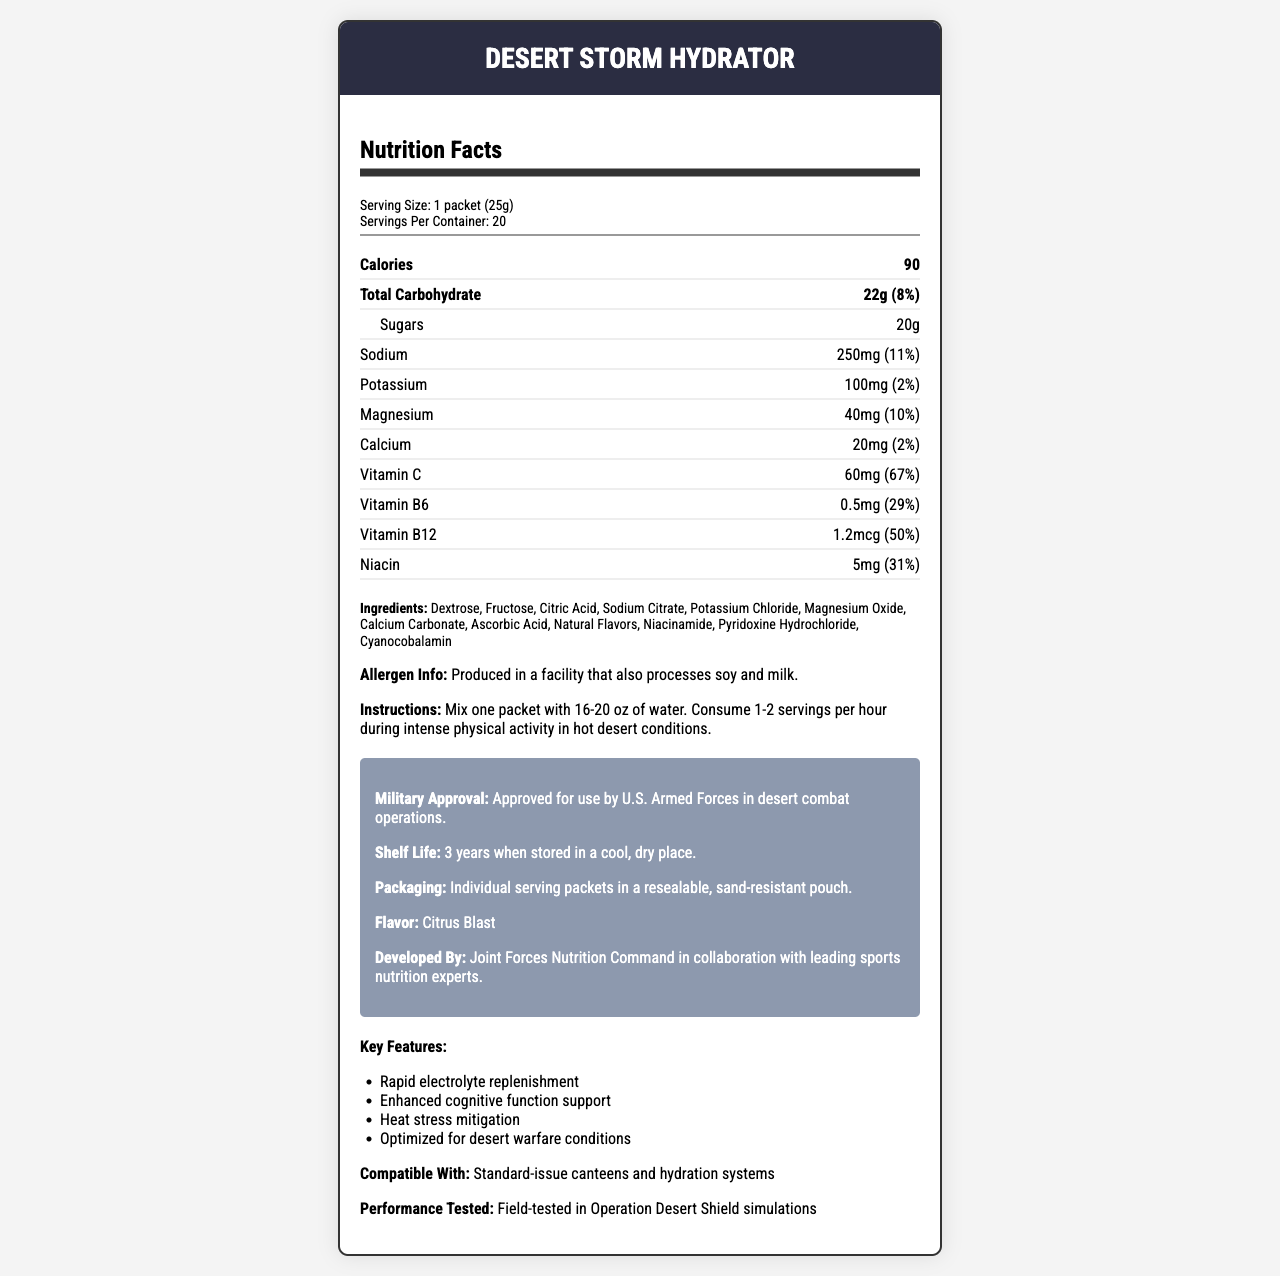what is the serving size for Desert Storm Hydrator? The document lists the serving size as 1 packet (25g).
Answer: 1 packet (25g) how many packets are there in each container? The servings per container are 20, which implies there are 20 packets.
Answer: 20 how many calories are in one serving? The document specifies that there are 90 calories per serving.
Answer: 90 how much sugar is in one serving? The sugar content per serving is listed as 20g.
Answer: 20g what are the ingredients listed for Desert Storm Hydrator? The ingredients are clearly listed in the document.
Answer: Dextrose, Fructose, Citric Acid, Sodium Citrate, Potassium Chloride, Magnesium Oxide, Calcium Carbonate, Ascorbic Acid, Natural Flavors, Niacinamide, Pyridoxine Hydrochloride, Cyanocobalamin how much sodium is in one serving of Desert Storm Hydrator? The document specifies that one serving contains 250mg of sodium.
Answer: 250mg which vitamin has the highest percentage of the daily value per serving? A. Vitamin C B. Vitamin B6 C. Vitamin B12 D. Niacin The document indicates Vitamin C at 67%, while Vitamin B6 is 29%, Vitamin B12 is 50%, and Niacin is 31%.
Answer: A. Vitamin C what flavor is Desert Storm Hydrator? A. Berry Burst B. Tropical Punch C. Citrus Blast D. Lemon Lime The document specifies the flavor as Citrus Blast.
Answer: C. Citrus Blast can Desert Storm Hydrator be used with standard-issue canteens and hydration systems? The document states that the product is compatible with standard-issue canteens and hydration systems.
Answer: Yes what is the shelf life of Desert Storm Hydrator? The document specifies a shelf life of 3 years when stored in a cool, dry place.
Answer: 3 years when stored in a cool, dry place summarize the main idea of this document. The document provides detailed nutrition information, ingredients, usage instructions, and key features of the Desert Storm Hydrator, showing its suitability for military use in desert conditions.
Answer: A Nutrition Facts Label for Desert Storm Hydrator, a hydration drink mix designed for desert combat scenarios. The drink contains electrolytes and vitamins, is military-approved, has a long shelf life, and is compatible with standard military gear. what is the combined total daily value percentage of vitamin B6 and vitamin B12 per serving? Vitamin B6 has 29% and Vitamin B12 has 50%, adding up to 79%.
Answer: 79% what is the product name? The product name mentioned in the document is Desert Storm Hydrator.
Answer: Desert Storm Hydrator is the Desert Storm Hydrator safe for someone with a soy or milk allergy? The allergen information states it is produced in a facility that processes soy and milk, posing a risk for someone with allergies.
Answer: No who developed Desert Storm Hydrator? The document states that the drink was developed by the Joint Forces Nutrition Command in collaboration with leading sports nutrition experts.
Answer: Joint Forces Nutrition Command in collaboration with leading sports nutrition experts are there any uses of artificial flavors in the ingredients? The ingredients listed include 'Natural Flavors,' indicating no artificial flavors.
Answer: No what are the instructions for consuming Desert Storm Hydrator during intense physical activity? The document outlines the mixing and consumption instructions clearly.
Answer: Mix one packet with 16-20 oz of water. Consume 1-2 servings per hour during intense physical activity in hot desert conditions. what are the key features of Desert Storm Hydrator? The key features listed in the document are rapid electrolyte replenishment, enhanced cognitive function support, heat stress mitigation, and optimization for desert warfare conditions.
Answer: Rapid electrolyte replenishment, Enhanced cognitive function support, Heat stress mitigation, Optimized for desert warfare conditions what percentage of the daily value of potassium does one serving provide? The document indicates that one serving provides 2% of the daily value for potassium.
Answer: 2% how many calories come from carbohydrates if all calories in the serving come from carbohydrates? The document shows 22g of carbohydrates per serving and each gram of carbohydrate provides 4 calories, resulting in 88 calories, which is close to the document's 90 calories per serving, implying all calories likely come from carbohydrates.
Answer: 90 calories what is the purpose of the specific approval from the U.S. Armed Forces? The document mentions approval by U.S. Armed Forces in desert combat operations, but does not explain the specific purpose of this approval.
Answer: Not enough information 